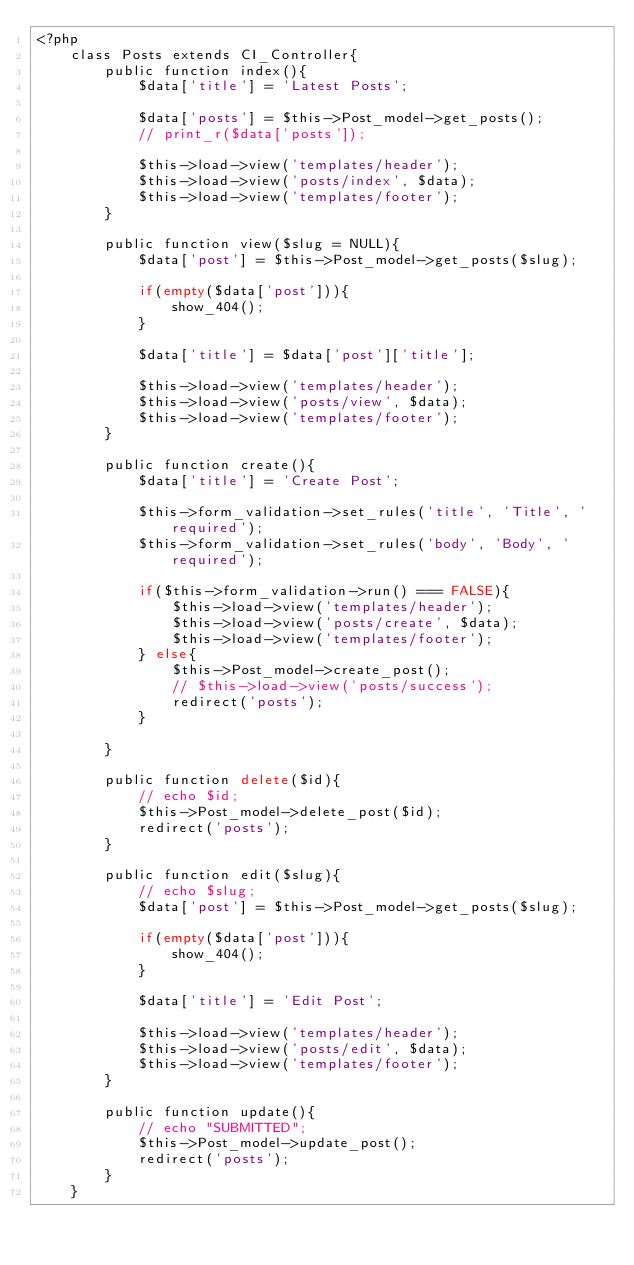Convert code to text. <code><loc_0><loc_0><loc_500><loc_500><_PHP_><?php
	class Posts extends CI_Controller{
		public function index(){
			$data['title'] = 'Latest Posts';

			$data['posts'] = $this->Post_model->get_posts();
			// print_r($data['posts']);

			$this->load->view('templates/header');
			$this->load->view('posts/index', $data);
			$this->load->view('templates/footer');
		}

		public function view($slug = NULL){
			$data['post'] = $this->Post_model->get_posts($slug);

			if(empty($data['post'])){
				show_404();
			}

			$data['title'] = $data['post']['title'];

			$this->load->view('templates/header');
			$this->load->view('posts/view', $data);
			$this->load->view('templates/footer');
		}

		public function create(){
			$data['title'] = 'Create Post';

			$this->form_validation->set_rules('title', 'Title', 'required');
			$this->form_validation->set_rules('body', 'Body', 'required');

			if($this->form_validation->run() === FALSE){
				$this->load->view('templates/header');
				$this->load->view('posts/create', $data);
				$this->load->view('templates/footer');
			} else{
				$this->Post_model->create_post();
				// $this->load->view('posts/success');
				redirect('posts');
			}

		}

		public function delete($id){
			// echo $id;
			$this->Post_model->delete_post($id);
			redirect('posts');
		}

		public function edit($slug){
			// echo $slug;
			$data['post'] = $this->Post_model->get_posts($slug);

			if(empty($data['post'])){
				show_404();
			}

			$data['title'] = 'Edit Post';

			$this->load->view('templates/header');
			$this->load->view('posts/edit', $data);
			$this->load->view('templates/footer');
		}

		public function update(){
			// echo "SUBMITTED";
			$this->Post_model->update_post();
			redirect('posts');
		}
	}
</code> 